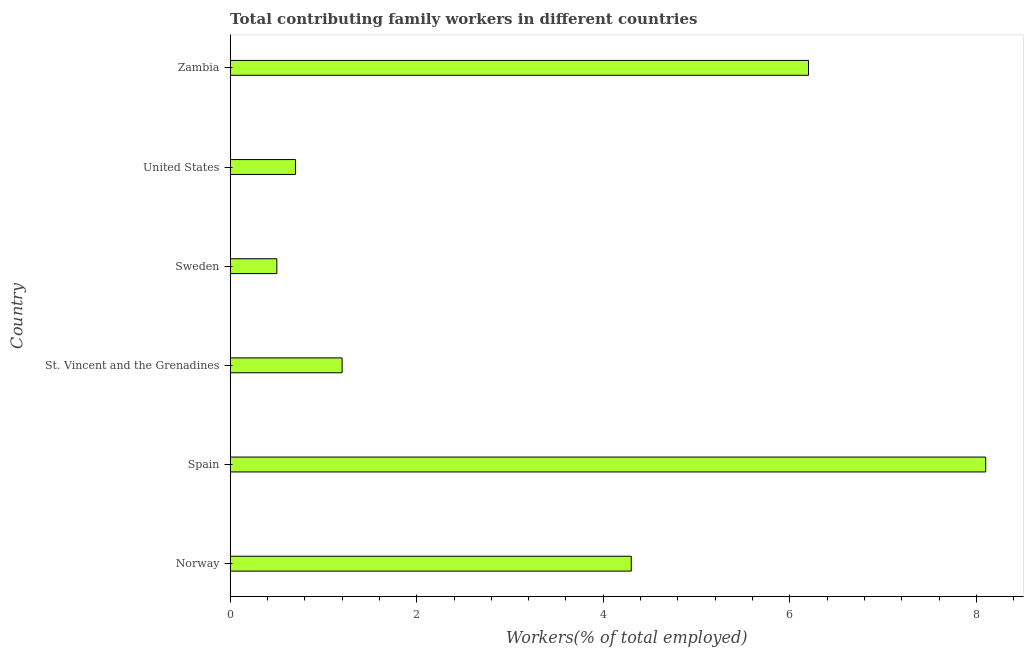What is the title of the graph?
Provide a succinct answer. Total contributing family workers in different countries. What is the label or title of the X-axis?
Offer a very short reply. Workers(% of total employed). What is the label or title of the Y-axis?
Ensure brevity in your answer.  Country. What is the contributing family workers in St. Vincent and the Grenadines?
Your answer should be very brief. 1.2. Across all countries, what is the maximum contributing family workers?
Offer a very short reply. 8.1. Across all countries, what is the minimum contributing family workers?
Offer a terse response. 0.5. In which country was the contributing family workers minimum?
Ensure brevity in your answer.  Sweden. What is the sum of the contributing family workers?
Keep it short and to the point. 21. What is the difference between the contributing family workers in Spain and Sweden?
Ensure brevity in your answer.  7.6. What is the average contributing family workers per country?
Provide a succinct answer. 3.5. What is the median contributing family workers?
Provide a short and direct response. 2.75. What is the ratio of the contributing family workers in Sweden to that in United States?
Ensure brevity in your answer.  0.71. Is the difference between the contributing family workers in Spain and St. Vincent and the Grenadines greater than the difference between any two countries?
Your answer should be compact. No. In how many countries, is the contributing family workers greater than the average contributing family workers taken over all countries?
Give a very brief answer. 3. What is the difference between two consecutive major ticks on the X-axis?
Make the answer very short. 2. What is the Workers(% of total employed) in Norway?
Your answer should be very brief. 4.3. What is the Workers(% of total employed) in Spain?
Make the answer very short. 8.1. What is the Workers(% of total employed) in St. Vincent and the Grenadines?
Your response must be concise. 1.2. What is the Workers(% of total employed) of Sweden?
Your response must be concise. 0.5. What is the Workers(% of total employed) in United States?
Ensure brevity in your answer.  0.7. What is the Workers(% of total employed) in Zambia?
Keep it short and to the point. 6.2. What is the difference between the Workers(% of total employed) in Norway and Spain?
Your response must be concise. -3.8. What is the difference between the Workers(% of total employed) in Norway and Sweden?
Ensure brevity in your answer.  3.8. What is the difference between the Workers(% of total employed) in Spain and Sweden?
Provide a succinct answer. 7.6. What is the difference between the Workers(% of total employed) in Spain and United States?
Your answer should be compact. 7.4. What is the difference between the Workers(% of total employed) in Sweden and United States?
Your answer should be compact. -0.2. What is the ratio of the Workers(% of total employed) in Norway to that in Spain?
Provide a short and direct response. 0.53. What is the ratio of the Workers(% of total employed) in Norway to that in St. Vincent and the Grenadines?
Give a very brief answer. 3.58. What is the ratio of the Workers(% of total employed) in Norway to that in United States?
Offer a very short reply. 6.14. What is the ratio of the Workers(% of total employed) in Norway to that in Zambia?
Make the answer very short. 0.69. What is the ratio of the Workers(% of total employed) in Spain to that in St. Vincent and the Grenadines?
Offer a terse response. 6.75. What is the ratio of the Workers(% of total employed) in Spain to that in United States?
Offer a very short reply. 11.57. What is the ratio of the Workers(% of total employed) in Spain to that in Zambia?
Your answer should be compact. 1.31. What is the ratio of the Workers(% of total employed) in St. Vincent and the Grenadines to that in United States?
Your answer should be very brief. 1.71. What is the ratio of the Workers(% of total employed) in St. Vincent and the Grenadines to that in Zambia?
Offer a very short reply. 0.19. What is the ratio of the Workers(% of total employed) in Sweden to that in United States?
Give a very brief answer. 0.71. What is the ratio of the Workers(% of total employed) in Sweden to that in Zambia?
Your answer should be very brief. 0.08. What is the ratio of the Workers(% of total employed) in United States to that in Zambia?
Offer a very short reply. 0.11. 